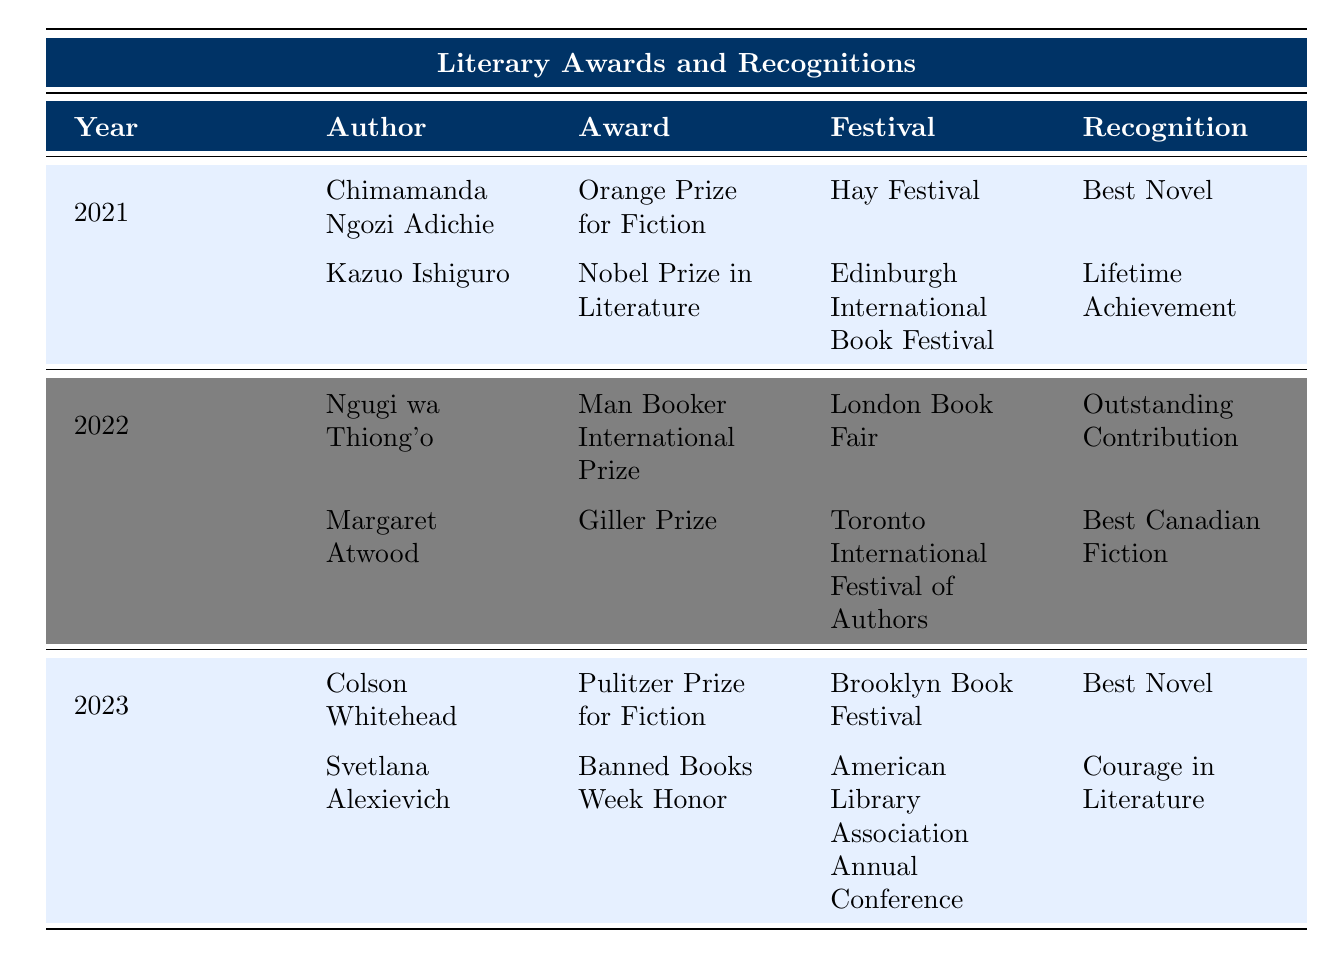What author won the Nobel Prize in Literature at the Edinburgh International Book Festival? According to the table, Kazuo Ishiguro is listed as the author who won the Nobel Prize in Literature at the Edinburgh International Book Festival in 2021.
Answer: Kazuo Ishiguro Which recognition was awarded to Colson Whitehead in 2023? The table states that Colson Whitehead received the recognition of "Best Novel" for the Pulitzer Prize for Fiction in 2023.
Answer: Best Novel How many authors were recognized in the year 2022? In the table, there are two authors listed for the year 2022: Ngugi wa Thiong'o and Margaret Atwood.
Answer: 2 Did Chimamanda Ngozi Adichie receive an award for non-fiction? The table shows that Chimamanda Ngozi Adichie received the Orange Prize for Fiction in 2021, which is a fiction award, thus she did not receive an award for non-fiction.
Answer: No Which festival hosted the Man Booker International Prize in 2022? The table indicates that the Man Booker International Prize was awarded at the London Book Fair in 2022.
Answer: London Book Fair Which award did Margaret Atwood receive in 2022? The table specifies that Margaret Atwood received the Giller Prize in 2022.
Answer: Giller Prize How many different categories of awards were represented in the table? By analyzing the table, there are two categories: Fiction and Non-Fiction. Both categories were represented across the years listed.
Answer: 2 What is the total number of different festivals mentioned in the table? Counting the festivals from the table: Hay Festival, Edinburgh International Book Festival, London Book Fair, Toronto International Festival of Authors, Brooklyn Book Festival, and American Library Association Annual Conference yields a total of six different festivals.
Answer: 6 Which author received the award for "Courage in Literature"? Svetlana Alexievich is noted in the table as receiving the Banned Books Week Honor for "Courage in Literature" in 2023.
Answer: Svetlana Alexievich What award is associated with the Brooklyn Book Festival? The table shows that the Pulitzer Prize for Fiction is the award associated with the Brooklyn Book Festival in 2023, where Colson Whitehead was recognized.
Answer: Pulitzer Prize for Fiction 